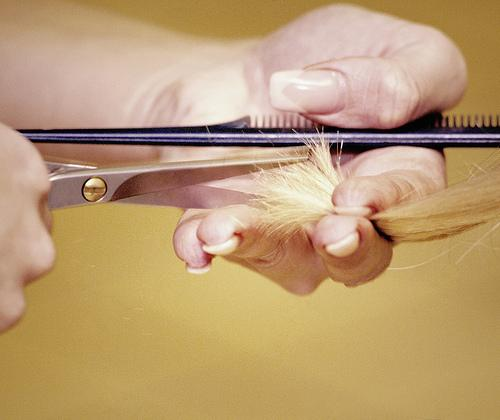What emotion does this image evoke in a viewer? The image can evoke a sense of relaxation and satisfaction as it represents a grooming activity and professional care provided by the hairdresser. Write a poetic description of the scene in the image. Amidst a golden aura, hands delicately dance on strands of sun-kissed hair, where steel meets art, and a black comb grants style its fair share. Describe the state of the hairdresser's nails in the image. The hairdresser has well-manicured, shiny fingernails with long finger nails. Create a question about the quality of the customer's hair. How is the overall condition of the customer's blonde hair, considering the presence of split ends? Discuss the importance of proper tool usage in a hairdresser's work. Precision slicing by stainless steel scissors, and the steady motion of a black comb, unite in the skilled hands of a hairdresser to shape and mold tresses into stunning visual appeal. Count the total number of visible fingers in the image. 9 fingers are visible in the image. What is the main action happening with the scissors in the image? The scissors are being used to cut the ends of the customer's blonde hair. What is the hairdresser doing in the picture? The hairdresser is trimming a customer's blonde hair using scissors and holding a black comb. Analyze the interaction between the hairdresser's hands and tools. The hairdresser's right hand skillfully controls the scissors, while the left hand firmly holds the comb and guides the blonde hair, ensuring a precise and effective trimming process. List the primary objects in the image. scissors, hair, comb, fingernails, hands, gold-background, brass screw, knuckles. 